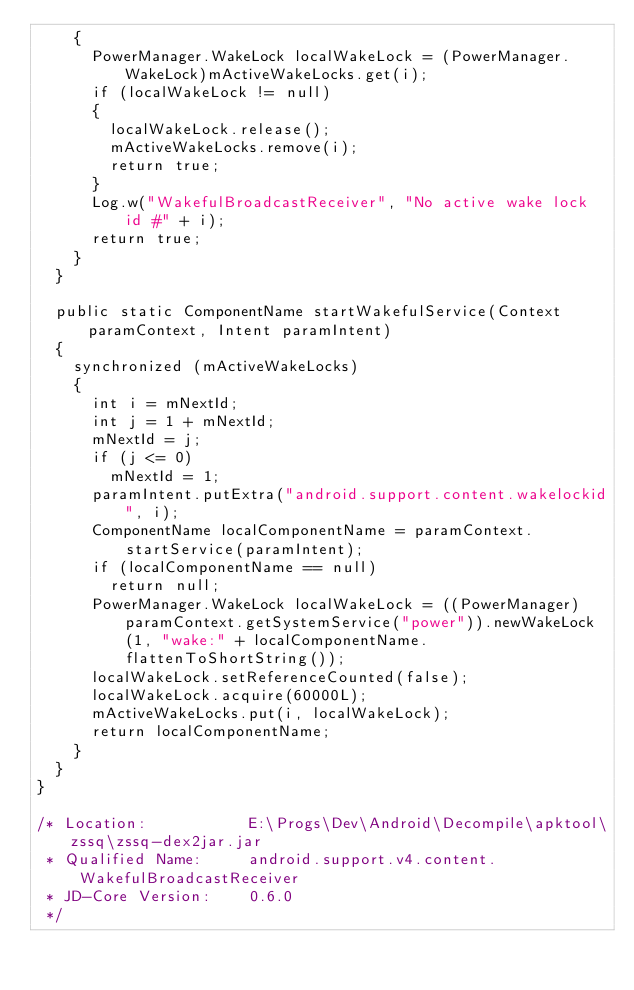Convert code to text. <code><loc_0><loc_0><loc_500><loc_500><_Java_>    {
      PowerManager.WakeLock localWakeLock = (PowerManager.WakeLock)mActiveWakeLocks.get(i);
      if (localWakeLock != null)
      {
        localWakeLock.release();
        mActiveWakeLocks.remove(i);
        return true;
      }
      Log.w("WakefulBroadcastReceiver", "No active wake lock id #" + i);
      return true;
    }
  }

  public static ComponentName startWakefulService(Context paramContext, Intent paramIntent)
  {
    synchronized (mActiveWakeLocks)
    {
      int i = mNextId;
      int j = 1 + mNextId;
      mNextId = j;
      if (j <= 0)
        mNextId = 1;
      paramIntent.putExtra("android.support.content.wakelockid", i);
      ComponentName localComponentName = paramContext.startService(paramIntent);
      if (localComponentName == null)
        return null;
      PowerManager.WakeLock localWakeLock = ((PowerManager)paramContext.getSystemService("power")).newWakeLock(1, "wake:" + localComponentName.flattenToShortString());
      localWakeLock.setReferenceCounted(false);
      localWakeLock.acquire(60000L);
      mActiveWakeLocks.put(i, localWakeLock);
      return localComponentName;
    }
  }
}

/* Location:           E:\Progs\Dev\Android\Decompile\apktool\zssq\zssq-dex2jar.jar
 * Qualified Name:     android.support.v4.content.WakefulBroadcastReceiver
 * JD-Core Version:    0.6.0
 */</code> 